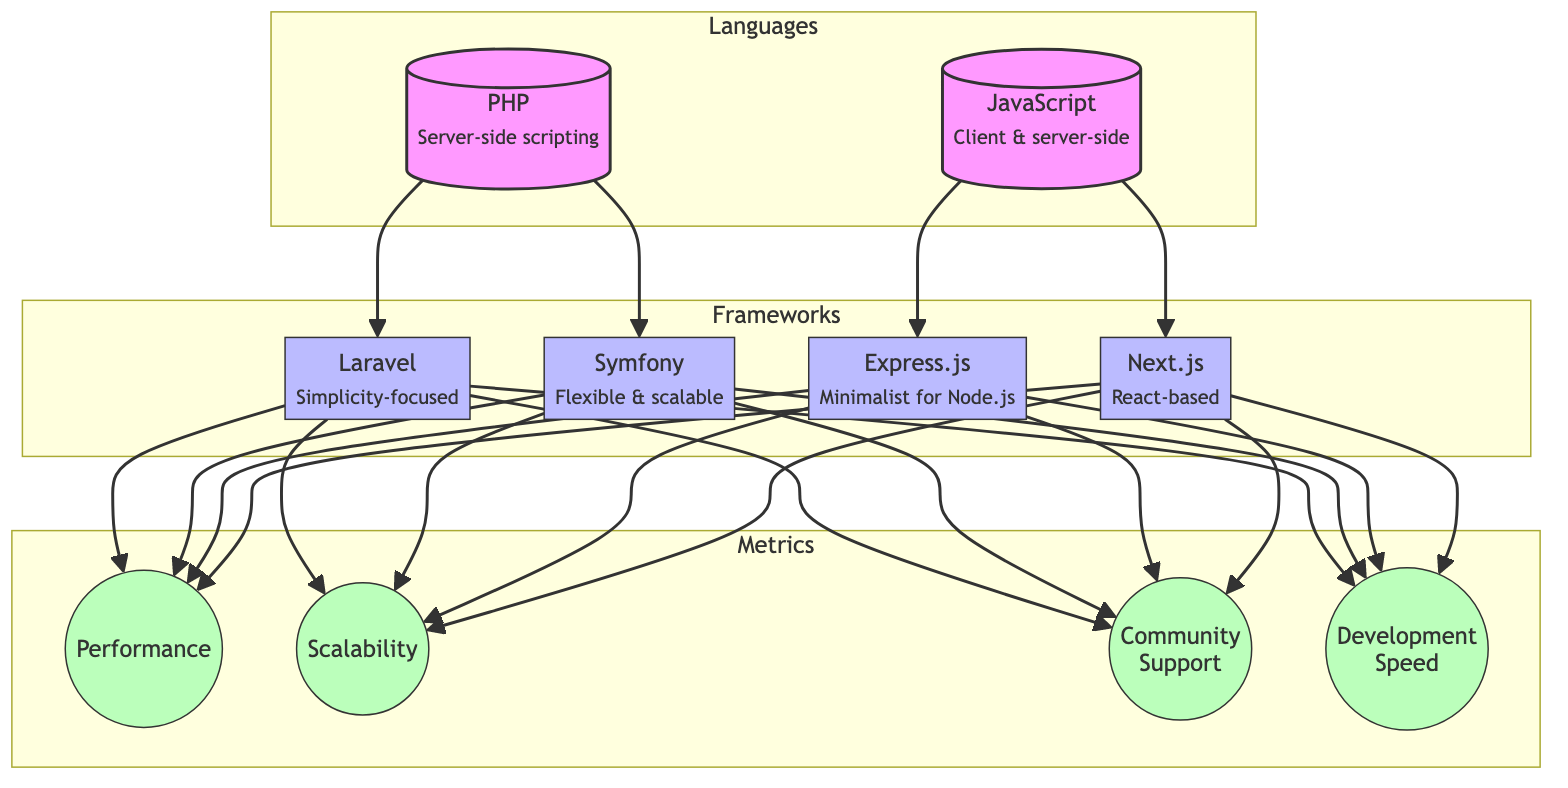What are the two main programming languages compared in the diagram? The diagram shows PHP and JavaScript as the two primary languages. These are the first nodes in the Languages subgraph and are connected to their respective frameworks.
Answer: PHP and JavaScript How many frameworks are represented in the diagram? There are four frameworks represented: Laravel, Symfony, Express.js, and Next.js. Each is connected to its corresponding language node.
Answer: Four Which PHP framework is highlighted for its simplicity? The PHP framework highlighted for its simplicity is Laravel, as indicated by the sub-label next to its node.
Answer: Laravel Which JavaScript framework is based on React? Next.js is identified as the React-based JavaScript framework, as stated in the sub-label beneath its node.
Answer: Next.js What metric is directly linked to both Laravel and Symfony? The metric linked to both Laravel and Symfony is performance, shown as a shared edge originating from both framework nodes.
Answer: Performance Which framework has the highest community support based on the diagram? The diagram does not specify which framework has the highest community support, but it indicates that all frameworks have links to the community support metric. Further analysis of external sources would be needed.
Answer: Not specified Which metric has connections to all four frameworks? The metric that has connections to all four frameworks is development speed, as it shows edges leading from Laravel, Symfony, Express, and Next.js.
Answer: Development speed Which programming language supports both client-side and server-side development? JavaScript supports both client-side and server-side development, as indicated by the description under its node in the diagram.
Answer: JavaScript What defines Symfony as a framework compared to Laravel based on the diagram? Symfony is characterized by being flexible and scalable, as per the sub-label beneath its node, while Laravel is noted for its simplicity.
Answer: Flexible and scalable 